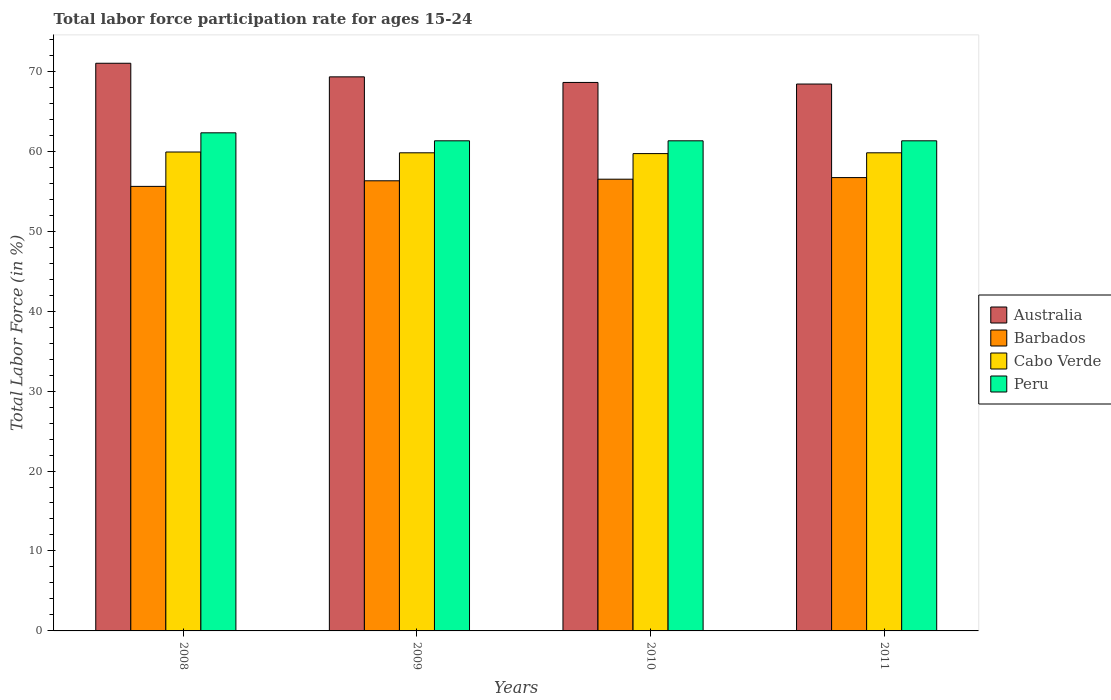How many different coloured bars are there?
Make the answer very short. 4. How many groups of bars are there?
Make the answer very short. 4. Are the number of bars per tick equal to the number of legend labels?
Provide a succinct answer. Yes. What is the label of the 4th group of bars from the left?
Offer a very short reply. 2011. What is the labor force participation rate in Barbados in 2009?
Offer a terse response. 56.3. Across all years, what is the maximum labor force participation rate in Cabo Verde?
Ensure brevity in your answer.  59.9. Across all years, what is the minimum labor force participation rate in Barbados?
Your answer should be compact. 55.6. In which year was the labor force participation rate in Barbados minimum?
Provide a succinct answer. 2008. What is the total labor force participation rate in Peru in the graph?
Keep it short and to the point. 246.2. What is the difference between the labor force participation rate in Peru in 2009 and that in 2010?
Provide a succinct answer. 0. What is the difference between the labor force participation rate in Barbados in 2010 and the labor force participation rate in Australia in 2009?
Provide a short and direct response. -12.8. What is the average labor force participation rate in Barbados per year?
Provide a succinct answer. 56.27. In the year 2008, what is the difference between the labor force participation rate in Peru and labor force participation rate in Australia?
Provide a succinct answer. -8.7. In how many years, is the labor force participation rate in Barbados greater than 56 %?
Provide a succinct answer. 3. What is the ratio of the labor force participation rate in Peru in 2009 to that in 2011?
Provide a succinct answer. 1. Is the labor force participation rate in Australia in 2008 less than that in 2010?
Make the answer very short. No. Is the difference between the labor force participation rate in Peru in 2009 and 2011 greater than the difference between the labor force participation rate in Australia in 2009 and 2011?
Your answer should be very brief. No. What is the difference between the highest and the second highest labor force participation rate in Barbados?
Offer a very short reply. 0.2. Is the sum of the labor force participation rate in Cabo Verde in 2008 and 2011 greater than the maximum labor force participation rate in Australia across all years?
Keep it short and to the point. Yes. Is it the case that in every year, the sum of the labor force participation rate in Peru and labor force participation rate in Australia is greater than the sum of labor force participation rate in Cabo Verde and labor force participation rate in Barbados?
Provide a short and direct response. No. What does the 4th bar from the left in 2008 represents?
Ensure brevity in your answer.  Peru. What does the 2nd bar from the right in 2009 represents?
Ensure brevity in your answer.  Cabo Verde. How many bars are there?
Ensure brevity in your answer.  16. Are all the bars in the graph horizontal?
Your answer should be very brief. No. How many years are there in the graph?
Provide a short and direct response. 4. What is the difference between two consecutive major ticks on the Y-axis?
Offer a terse response. 10. Does the graph contain grids?
Make the answer very short. No. Where does the legend appear in the graph?
Keep it short and to the point. Center right. How many legend labels are there?
Give a very brief answer. 4. What is the title of the graph?
Provide a short and direct response. Total labor force participation rate for ages 15-24. What is the label or title of the X-axis?
Give a very brief answer. Years. What is the label or title of the Y-axis?
Your answer should be compact. Total Labor Force (in %). What is the Total Labor Force (in %) in Australia in 2008?
Ensure brevity in your answer.  71. What is the Total Labor Force (in %) of Barbados in 2008?
Offer a terse response. 55.6. What is the Total Labor Force (in %) in Cabo Verde in 2008?
Your answer should be very brief. 59.9. What is the Total Labor Force (in %) in Peru in 2008?
Ensure brevity in your answer.  62.3. What is the Total Labor Force (in %) of Australia in 2009?
Provide a succinct answer. 69.3. What is the Total Labor Force (in %) of Barbados in 2009?
Provide a succinct answer. 56.3. What is the Total Labor Force (in %) of Cabo Verde in 2009?
Offer a very short reply. 59.8. What is the Total Labor Force (in %) of Peru in 2009?
Make the answer very short. 61.3. What is the Total Labor Force (in %) of Australia in 2010?
Provide a succinct answer. 68.6. What is the Total Labor Force (in %) in Barbados in 2010?
Make the answer very short. 56.5. What is the Total Labor Force (in %) in Cabo Verde in 2010?
Provide a short and direct response. 59.7. What is the Total Labor Force (in %) of Peru in 2010?
Your answer should be compact. 61.3. What is the Total Labor Force (in %) of Australia in 2011?
Ensure brevity in your answer.  68.4. What is the Total Labor Force (in %) of Barbados in 2011?
Give a very brief answer. 56.7. What is the Total Labor Force (in %) of Cabo Verde in 2011?
Offer a terse response. 59.8. What is the Total Labor Force (in %) in Peru in 2011?
Keep it short and to the point. 61.3. Across all years, what is the maximum Total Labor Force (in %) of Barbados?
Provide a succinct answer. 56.7. Across all years, what is the maximum Total Labor Force (in %) in Cabo Verde?
Make the answer very short. 59.9. Across all years, what is the maximum Total Labor Force (in %) of Peru?
Your answer should be compact. 62.3. Across all years, what is the minimum Total Labor Force (in %) of Australia?
Your answer should be very brief. 68.4. Across all years, what is the minimum Total Labor Force (in %) of Barbados?
Offer a terse response. 55.6. Across all years, what is the minimum Total Labor Force (in %) of Cabo Verde?
Give a very brief answer. 59.7. Across all years, what is the minimum Total Labor Force (in %) of Peru?
Keep it short and to the point. 61.3. What is the total Total Labor Force (in %) of Australia in the graph?
Provide a succinct answer. 277.3. What is the total Total Labor Force (in %) in Barbados in the graph?
Your answer should be very brief. 225.1. What is the total Total Labor Force (in %) in Cabo Verde in the graph?
Your response must be concise. 239.2. What is the total Total Labor Force (in %) of Peru in the graph?
Keep it short and to the point. 246.2. What is the difference between the Total Labor Force (in %) in Australia in 2008 and that in 2009?
Offer a terse response. 1.7. What is the difference between the Total Labor Force (in %) in Barbados in 2008 and that in 2009?
Your response must be concise. -0.7. What is the difference between the Total Labor Force (in %) in Cabo Verde in 2008 and that in 2010?
Make the answer very short. 0.2. What is the difference between the Total Labor Force (in %) of Peru in 2008 and that in 2010?
Your response must be concise. 1. What is the difference between the Total Labor Force (in %) in Australia in 2008 and that in 2011?
Offer a terse response. 2.6. What is the difference between the Total Labor Force (in %) of Barbados in 2008 and that in 2011?
Keep it short and to the point. -1.1. What is the difference between the Total Labor Force (in %) in Cabo Verde in 2008 and that in 2011?
Your answer should be compact. 0.1. What is the difference between the Total Labor Force (in %) in Australia in 2009 and that in 2010?
Give a very brief answer. 0.7. What is the difference between the Total Labor Force (in %) of Barbados in 2009 and that in 2010?
Offer a terse response. -0.2. What is the difference between the Total Labor Force (in %) in Cabo Verde in 2009 and that in 2010?
Ensure brevity in your answer.  0.1. What is the difference between the Total Labor Force (in %) of Peru in 2009 and that in 2010?
Your answer should be compact. 0. What is the difference between the Total Labor Force (in %) of Australia in 2009 and that in 2011?
Your answer should be compact. 0.9. What is the difference between the Total Labor Force (in %) in Barbados in 2009 and that in 2011?
Provide a short and direct response. -0.4. What is the difference between the Total Labor Force (in %) of Peru in 2009 and that in 2011?
Keep it short and to the point. 0. What is the difference between the Total Labor Force (in %) in Barbados in 2010 and that in 2011?
Provide a short and direct response. -0.2. What is the difference between the Total Labor Force (in %) in Peru in 2010 and that in 2011?
Offer a terse response. 0. What is the difference between the Total Labor Force (in %) in Australia in 2008 and the Total Labor Force (in %) in Barbados in 2009?
Ensure brevity in your answer.  14.7. What is the difference between the Total Labor Force (in %) of Barbados in 2008 and the Total Labor Force (in %) of Peru in 2009?
Your answer should be very brief. -5.7. What is the difference between the Total Labor Force (in %) in Cabo Verde in 2008 and the Total Labor Force (in %) in Peru in 2009?
Provide a short and direct response. -1.4. What is the difference between the Total Labor Force (in %) in Australia in 2008 and the Total Labor Force (in %) in Peru in 2010?
Your response must be concise. 9.7. What is the difference between the Total Labor Force (in %) in Australia in 2008 and the Total Labor Force (in %) in Peru in 2011?
Offer a very short reply. 9.7. What is the difference between the Total Labor Force (in %) of Barbados in 2008 and the Total Labor Force (in %) of Cabo Verde in 2011?
Provide a short and direct response. -4.2. What is the difference between the Total Labor Force (in %) of Cabo Verde in 2008 and the Total Labor Force (in %) of Peru in 2011?
Provide a short and direct response. -1.4. What is the difference between the Total Labor Force (in %) in Australia in 2009 and the Total Labor Force (in %) in Cabo Verde in 2010?
Your answer should be compact. 9.6. What is the difference between the Total Labor Force (in %) of Australia in 2009 and the Total Labor Force (in %) of Peru in 2010?
Offer a very short reply. 8. What is the difference between the Total Labor Force (in %) in Barbados in 2009 and the Total Labor Force (in %) in Cabo Verde in 2010?
Offer a very short reply. -3.4. What is the difference between the Total Labor Force (in %) of Barbados in 2009 and the Total Labor Force (in %) of Peru in 2010?
Provide a succinct answer. -5. What is the difference between the Total Labor Force (in %) in Cabo Verde in 2009 and the Total Labor Force (in %) in Peru in 2010?
Offer a very short reply. -1.5. What is the difference between the Total Labor Force (in %) of Australia in 2009 and the Total Labor Force (in %) of Barbados in 2011?
Provide a short and direct response. 12.6. What is the difference between the Total Labor Force (in %) in Australia in 2009 and the Total Labor Force (in %) in Peru in 2011?
Give a very brief answer. 8. What is the difference between the Total Labor Force (in %) in Barbados in 2009 and the Total Labor Force (in %) in Cabo Verde in 2011?
Your response must be concise. -3.5. What is the difference between the Total Labor Force (in %) of Barbados in 2009 and the Total Labor Force (in %) of Peru in 2011?
Give a very brief answer. -5. What is the difference between the Total Labor Force (in %) in Cabo Verde in 2009 and the Total Labor Force (in %) in Peru in 2011?
Offer a very short reply. -1.5. What is the difference between the Total Labor Force (in %) of Australia in 2010 and the Total Labor Force (in %) of Barbados in 2011?
Offer a very short reply. 11.9. What is the difference between the Total Labor Force (in %) in Barbados in 2010 and the Total Labor Force (in %) in Cabo Verde in 2011?
Your answer should be compact. -3.3. What is the difference between the Total Labor Force (in %) in Barbados in 2010 and the Total Labor Force (in %) in Peru in 2011?
Keep it short and to the point. -4.8. What is the average Total Labor Force (in %) in Australia per year?
Make the answer very short. 69.33. What is the average Total Labor Force (in %) in Barbados per year?
Offer a terse response. 56.27. What is the average Total Labor Force (in %) in Cabo Verde per year?
Offer a very short reply. 59.8. What is the average Total Labor Force (in %) of Peru per year?
Make the answer very short. 61.55. In the year 2008, what is the difference between the Total Labor Force (in %) in Australia and Total Labor Force (in %) in Barbados?
Give a very brief answer. 15.4. In the year 2008, what is the difference between the Total Labor Force (in %) in Australia and Total Labor Force (in %) in Cabo Verde?
Your response must be concise. 11.1. In the year 2008, what is the difference between the Total Labor Force (in %) in Australia and Total Labor Force (in %) in Peru?
Ensure brevity in your answer.  8.7. In the year 2008, what is the difference between the Total Labor Force (in %) in Cabo Verde and Total Labor Force (in %) in Peru?
Give a very brief answer. -2.4. In the year 2009, what is the difference between the Total Labor Force (in %) of Barbados and Total Labor Force (in %) of Cabo Verde?
Offer a very short reply. -3.5. In the year 2009, what is the difference between the Total Labor Force (in %) of Barbados and Total Labor Force (in %) of Peru?
Give a very brief answer. -5. In the year 2010, what is the difference between the Total Labor Force (in %) in Australia and Total Labor Force (in %) in Barbados?
Your answer should be very brief. 12.1. In the year 2010, what is the difference between the Total Labor Force (in %) of Australia and Total Labor Force (in %) of Cabo Verde?
Give a very brief answer. 8.9. In the year 2010, what is the difference between the Total Labor Force (in %) of Australia and Total Labor Force (in %) of Peru?
Offer a terse response. 7.3. In the year 2010, what is the difference between the Total Labor Force (in %) in Barbados and Total Labor Force (in %) in Cabo Verde?
Offer a terse response. -3.2. In the year 2010, what is the difference between the Total Labor Force (in %) of Barbados and Total Labor Force (in %) of Peru?
Offer a very short reply. -4.8. In the year 2011, what is the difference between the Total Labor Force (in %) in Australia and Total Labor Force (in %) in Barbados?
Your answer should be compact. 11.7. In the year 2011, what is the difference between the Total Labor Force (in %) in Australia and Total Labor Force (in %) in Cabo Verde?
Your answer should be compact. 8.6. In the year 2011, what is the difference between the Total Labor Force (in %) in Australia and Total Labor Force (in %) in Peru?
Give a very brief answer. 7.1. In the year 2011, what is the difference between the Total Labor Force (in %) of Cabo Verde and Total Labor Force (in %) of Peru?
Ensure brevity in your answer.  -1.5. What is the ratio of the Total Labor Force (in %) in Australia in 2008 to that in 2009?
Your response must be concise. 1.02. What is the ratio of the Total Labor Force (in %) of Barbados in 2008 to that in 2009?
Your answer should be very brief. 0.99. What is the ratio of the Total Labor Force (in %) in Peru in 2008 to that in 2009?
Ensure brevity in your answer.  1.02. What is the ratio of the Total Labor Force (in %) in Australia in 2008 to that in 2010?
Your response must be concise. 1.03. What is the ratio of the Total Labor Force (in %) in Barbados in 2008 to that in 2010?
Offer a terse response. 0.98. What is the ratio of the Total Labor Force (in %) in Peru in 2008 to that in 2010?
Ensure brevity in your answer.  1.02. What is the ratio of the Total Labor Force (in %) of Australia in 2008 to that in 2011?
Make the answer very short. 1.04. What is the ratio of the Total Labor Force (in %) of Barbados in 2008 to that in 2011?
Keep it short and to the point. 0.98. What is the ratio of the Total Labor Force (in %) of Cabo Verde in 2008 to that in 2011?
Give a very brief answer. 1. What is the ratio of the Total Labor Force (in %) of Peru in 2008 to that in 2011?
Make the answer very short. 1.02. What is the ratio of the Total Labor Force (in %) of Australia in 2009 to that in 2010?
Provide a succinct answer. 1.01. What is the ratio of the Total Labor Force (in %) in Australia in 2009 to that in 2011?
Your answer should be very brief. 1.01. What is the ratio of the Total Labor Force (in %) of Peru in 2009 to that in 2011?
Keep it short and to the point. 1. What is the difference between the highest and the second highest Total Labor Force (in %) in Cabo Verde?
Provide a succinct answer. 0.1. 